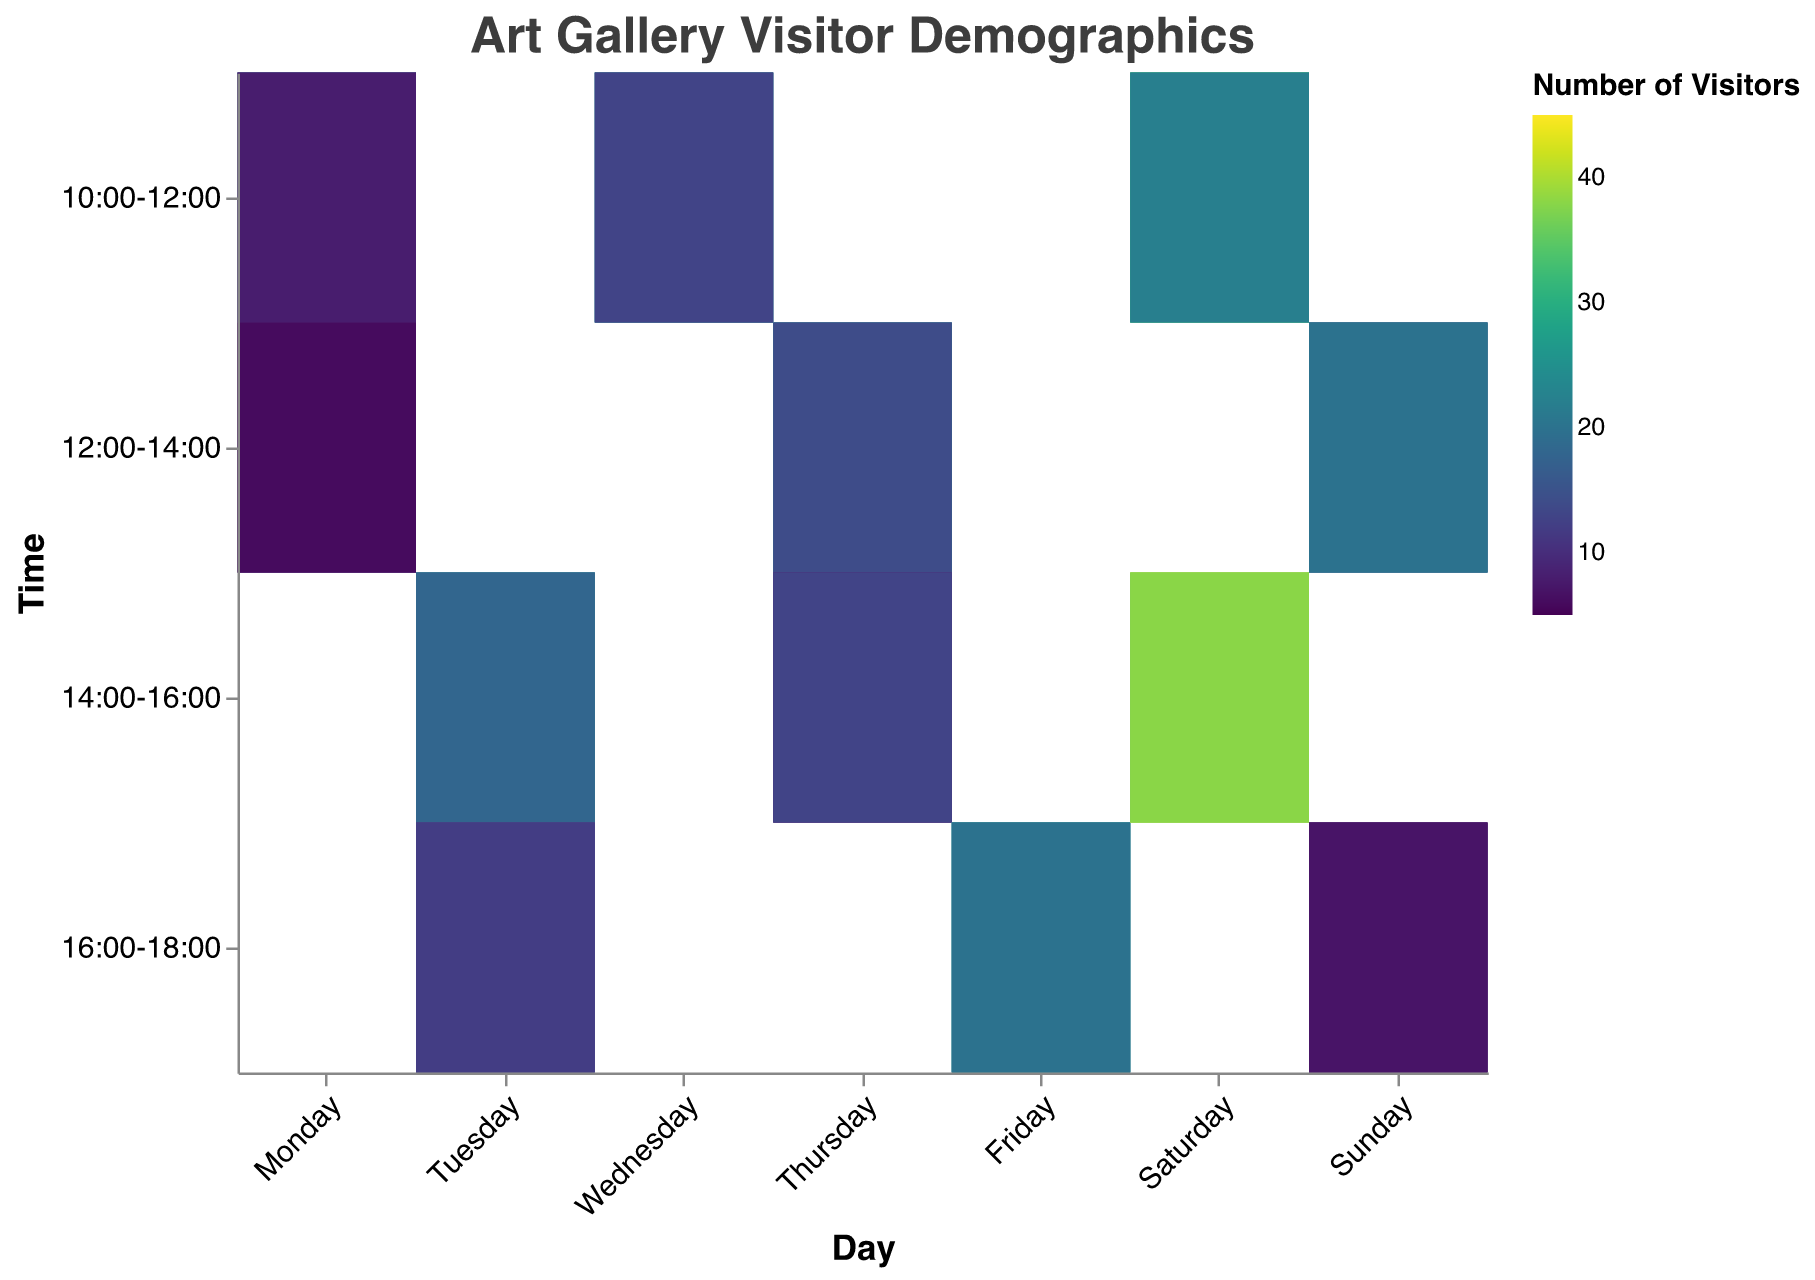what is the most popular time slot overall? By observing the most vibrant color in the heatmap, which indicates the highest number of visitors, we can find that the time slot with the highest aggregate number of visitors is 14:00-16:00 on Saturday.
Answer: 14:00-16:00 Which age group and gender combination has the highest number of visitors on a weekday? First, identify the weekdays on the x-axis (Monday to Friday). Then, look for the most vibrant color in this section associated with the Age_Group and Gender field on the tooltip. The combination 18-25 and Female on Wednesday from 10:00-12:00 has the highest number of visitors.
Answer: 18-25 Female compare the visitor count for males in the 18-25 age group between Monday 10:00-12:00 and Friday 16:00-18:00 Check the color shades for both Monday 10:00-12:00 and Friday 16:00-18:00 for the 18-25 Male group. The visitor count for Monday is 15 and for Friday is 20
Answer: 20 is greater than 15 what is the total number of visitors on Thursday? Add up visitor counts for Thursday across all age groups and time slots; 17 + 26 + 30 + 24 + 8 + 13 + 19 = 137.
Answer: 137 Which time slot on Saturday has more visitors in the 26-35 age group, 10:00-12:00 or 14:00-16:00? Check the color shades and tooltip information for the 26-35 age group on Saturday. The visitor count for 10:00-12:00 is 47 (25 male + 22 female), and for 14:00-16:00, it is 73 (35 male + 38 female)
Answer: 14:00-16:00 On which day does the 16:00-18:00 time slot have the lowest number of visitors overall? Examine the heatmap for the 16:00-18:00 row and check the tooltip data for each day. Sunday has the least visitors in this time slot with (10 male + 12 female + 5 male + 7 female) = 34 visitors.
Answer: Sunday are there more visitors in the 18-25 age group or the 26-35 age group overall on Tuesday? Sum up visitor numbers for both age groups on Tuesday: 18-25 (17 + 23 + 10 + 12) = 62, and 26-35 (20 + 18 + 13 + 12) = 63. Compare the two sums.
Answer: 26-35 has more visitors 